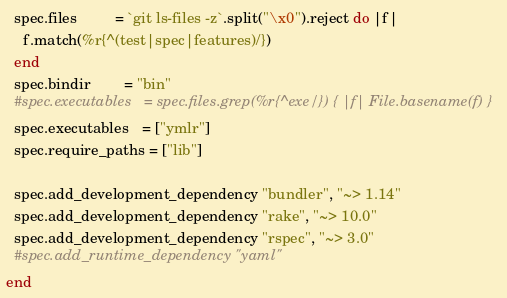<code> <loc_0><loc_0><loc_500><loc_500><_Ruby_>
  spec.files         = `git ls-files -z`.split("\x0").reject do |f|
    f.match(%r{^(test|spec|features)/})
  end
  spec.bindir        = "bin"
  #spec.executables   = spec.files.grep(%r{^exe/}) { |f| File.basename(f) }
  spec.executables   = ["ymlr"]
  spec.require_paths = ["lib"]

  spec.add_development_dependency "bundler", "~> 1.14"
  spec.add_development_dependency "rake", "~> 10.0"
  spec.add_development_dependency "rspec", "~> 3.0"
  #spec.add_runtime_dependency "yaml"
end
</code> 